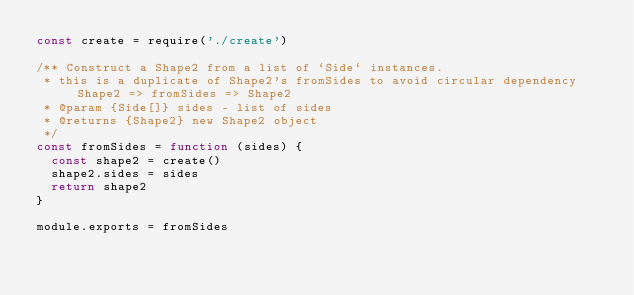Convert code to text. <code><loc_0><loc_0><loc_500><loc_500><_JavaScript_>const create = require('./create')

/** Construct a Shape2 from a list of `Side` instances.
 * this is a duplicate of Shape2's fromSides to avoid circular dependency Shape2 => fromSides => Shape2
 * @param {Side[]} sides - list of sides
 * @returns {Shape2} new Shape2 object
 */
const fromSides = function (sides) {
  const shape2 = create()
  shape2.sides = sides
  return shape2
}

module.exports = fromSides
</code> 